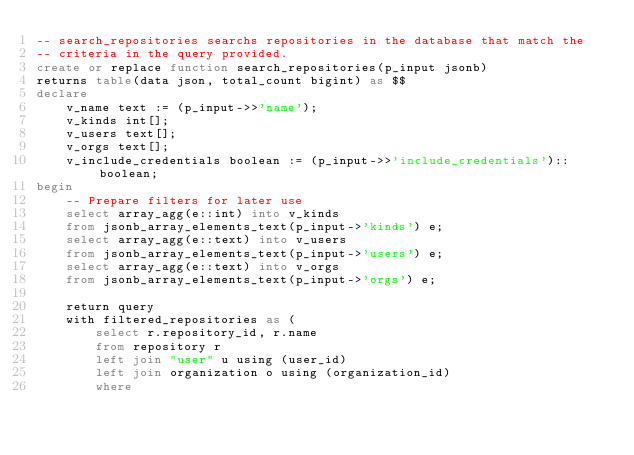Convert code to text. <code><loc_0><loc_0><loc_500><loc_500><_SQL_>-- search_repositories searchs repositories in the database that match the
-- criteria in the query provided.
create or replace function search_repositories(p_input jsonb)
returns table(data json, total_count bigint) as $$
declare
    v_name text := (p_input->>'name');
    v_kinds int[];
    v_users text[];
    v_orgs text[];
    v_include_credentials boolean := (p_input->>'include_credentials')::boolean;
begin
    -- Prepare filters for later use
    select array_agg(e::int) into v_kinds
    from jsonb_array_elements_text(p_input->'kinds') e;
    select array_agg(e::text) into v_users
    from jsonb_array_elements_text(p_input->'users') e;
    select array_agg(e::text) into v_orgs
    from jsonb_array_elements_text(p_input->'orgs') e;

    return query
    with filtered_repositories as (
        select r.repository_id, r.name
        from repository r
        left join "user" u using (user_id)
        left join organization o using (organization_id)
        where</code> 